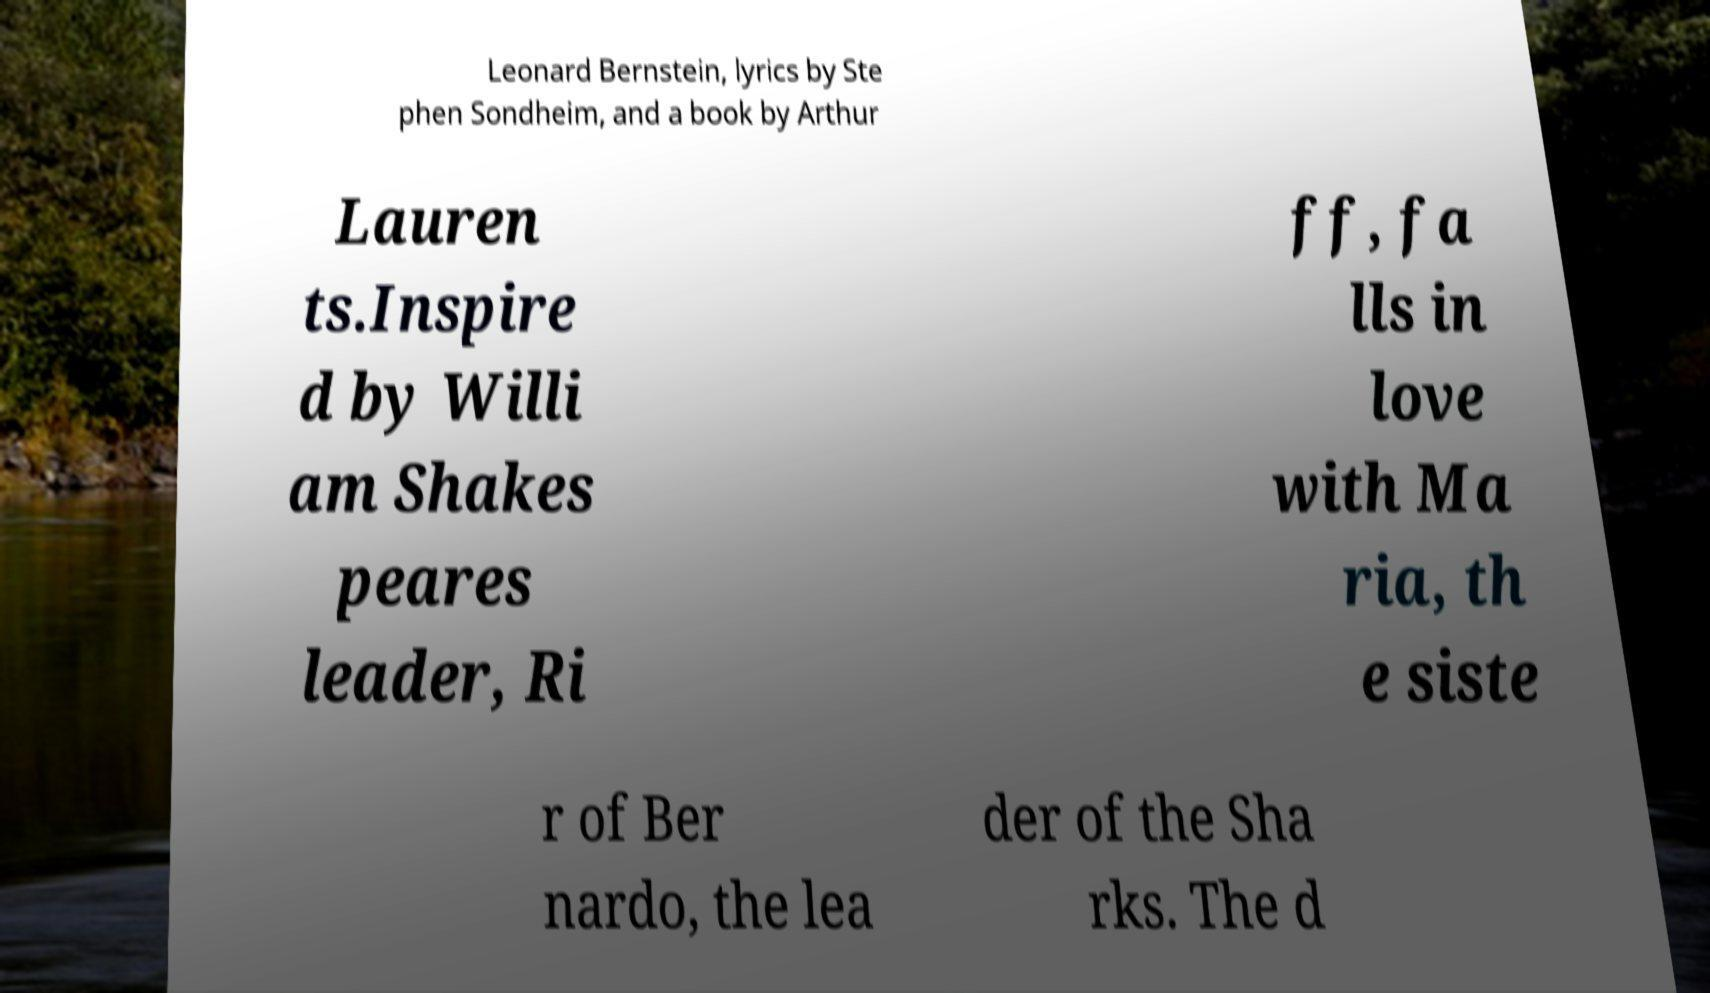Can you read and provide the text displayed in the image?This photo seems to have some interesting text. Can you extract and type it out for me? Leonard Bernstein, lyrics by Ste phen Sondheim, and a book by Arthur Lauren ts.Inspire d by Willi am Shakes peares leader, Ri ff, fa lls in love with Ma ria, th e siste r of Ber nardo, the lea der of the Sha rks. The d 